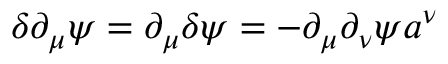<formula> <loc_0><loc_0><loc_500><loc_500>\delta \partial _ { \mu } \psi = \partial _ { \mu } \delta \psi = - \partial _ { \mu } \partial _ { \nu } \psi a ^ { \nu }</formula> 